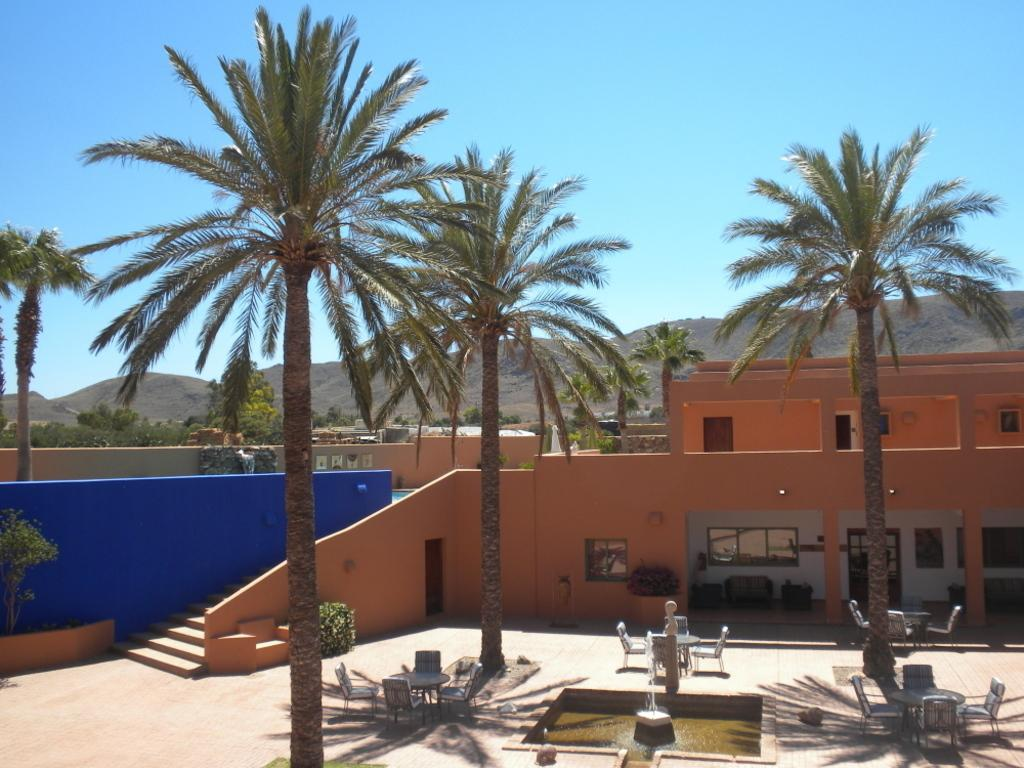What type of vegetation can be seen in the image? There are trees in the image. What architectural feature is present in the image? There are stairs in the image. What type of furniture is visible in the image? There are tables and chairs in the image. What body of water can be seen in the image? There is water visible in the image. What type of water feature is present in the image? There is a fountain in the image. What type of structures can be seen in the image? There are houses in the image. What part of the natural environment is visible in the image? The sky is visible in the image. What type of landscape feature is visible in the background of the image? There are hills in the background of the image. How does the tongue of the person in the image taste the heat of the rail? There is no person or rail present in the image, so this scenario cannot be observed. 